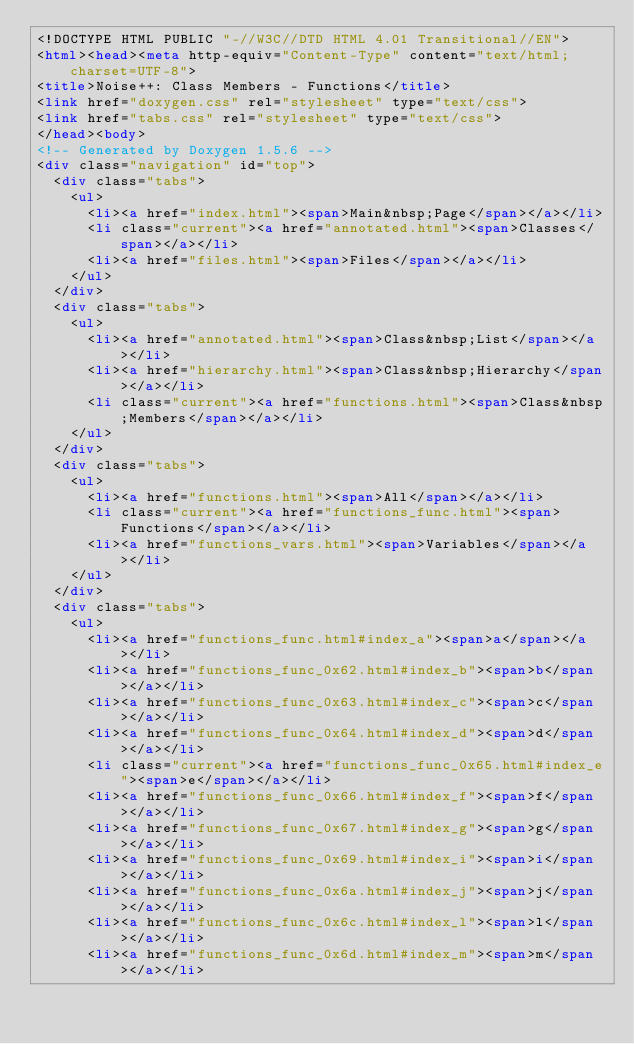Convert code to text. <code><loc_0><loc_0><loc_500><loc_500><_HTML_><!DOCTYPE HTML PUBLIC "-//W3C//DTD HTML 4.01 Transitional//EN">
<html><head><meta http-equiv="Content-Type" content="text/html;charset=UTF-8">
<title>Noise++: Class Members - Functions</title>
<link href="doxygen.css" rel="stylesheet" type="text/css">
<link href="tabs.css" rel="stylesheet" type="text/css">
</head><body>
<!-- Generated by Doxygen 1.5.6 -->
<div class="navigation" id="top">
  <div class="tabs">
    <ul>
      <li><a href="index.html"><span>Main&nbsp;Page</span></a></li>
      <li class="current"><a href="annotated.html"><span>Classes</span></a></li>
      <li><a href="files.html"><span>Files</span></a></li>
    </ul>
  </div>
  <div class="tabs">
    <ul>
      <li><a href="annotated.html"><span>Class&nbsp;List</span></a></li>
      <li><a href="hierarchy.html"><span>Class&nbsp;Hierarchy</span></a></li>
      <li class="current"><a href="functions.html"><span>Class&nbsp;Members</span></a></li>
    </ul>
  </div>
  <div class="tabs">
    <ul>
      <li><a href="functions.html"><span>All</span></a></li>
      <li class="current"><a href="functions_func.html"><span>Functions</span></a></li>
      <li><a href="functions_vars.html"><span>Variables</span></a></li>
    </ul>
  </div>
  <div class="tabs">
    <ul>
      <li><a href="functions_func.html#index_a"><span>a</span></a></li>
      <li><a href="functions_func_0x62.html#index_b"><span>b</span></a></li>
      <li><a href="functions_func_0x63.html#index_c"><span>c</span></a></li>
      <li><a href="functions_func_0x64.html#index_d"><span>d</span></a></li>
      <li class="current"><a href="functions_func_0x65.html#index_e"><span>e</span></a></li>
      <li><a href="functions_func_0x66.html#index_f"><span>f</span></a></li>
      <li><a href="functions_func_0x67.html#index_g"><span>g</span></a></li>
      <li><a href="functions_func_0x69.html#index_i"><span>i</span></a></li>
      <li><a href="functions_func_0x6a.html#index_j"><span>j</span></a></li>
      <li><a href="functions_func_0x6c.html#index_l"><span>l</span></a></li>
      <li><a href="functions_func_0x6d.html#index_m"><span>m</span></a></li></code> 